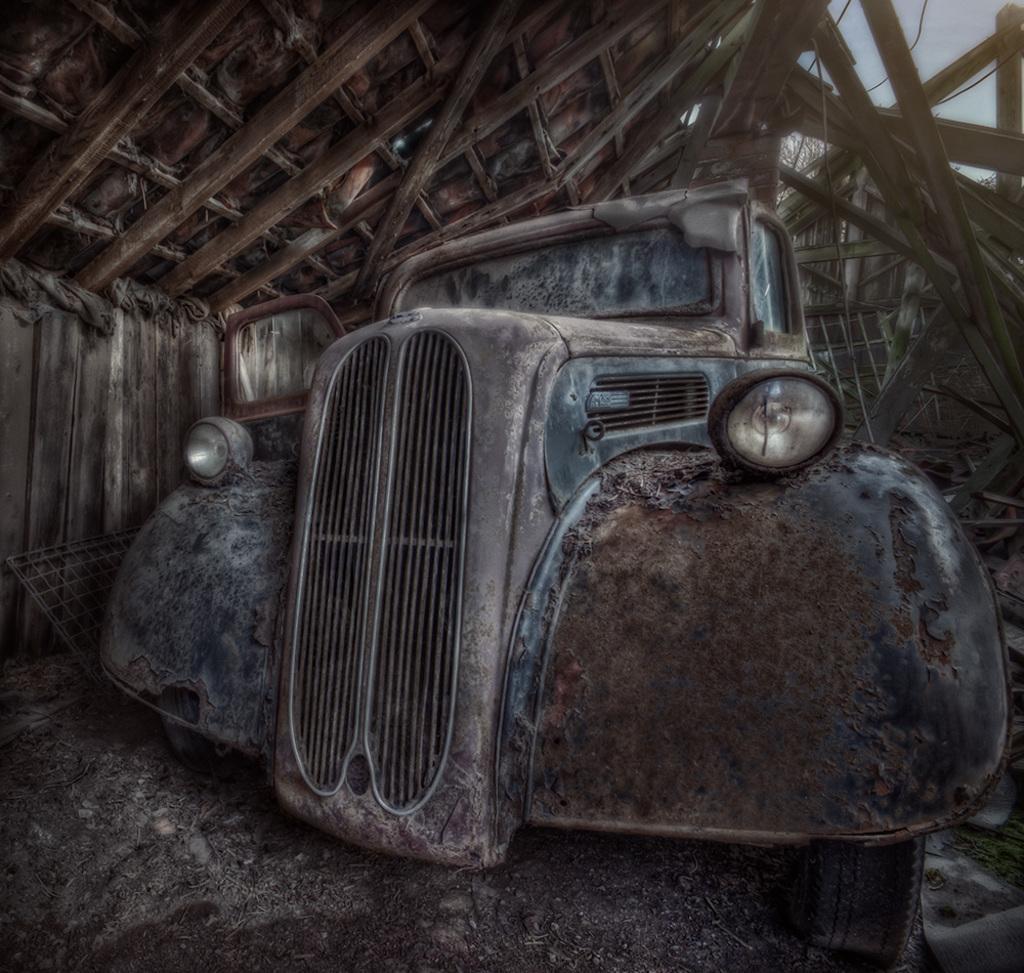How would you summarize this image in a sentence or two? This is an animated image. In this image, I can see an old car is placed under the shed. 